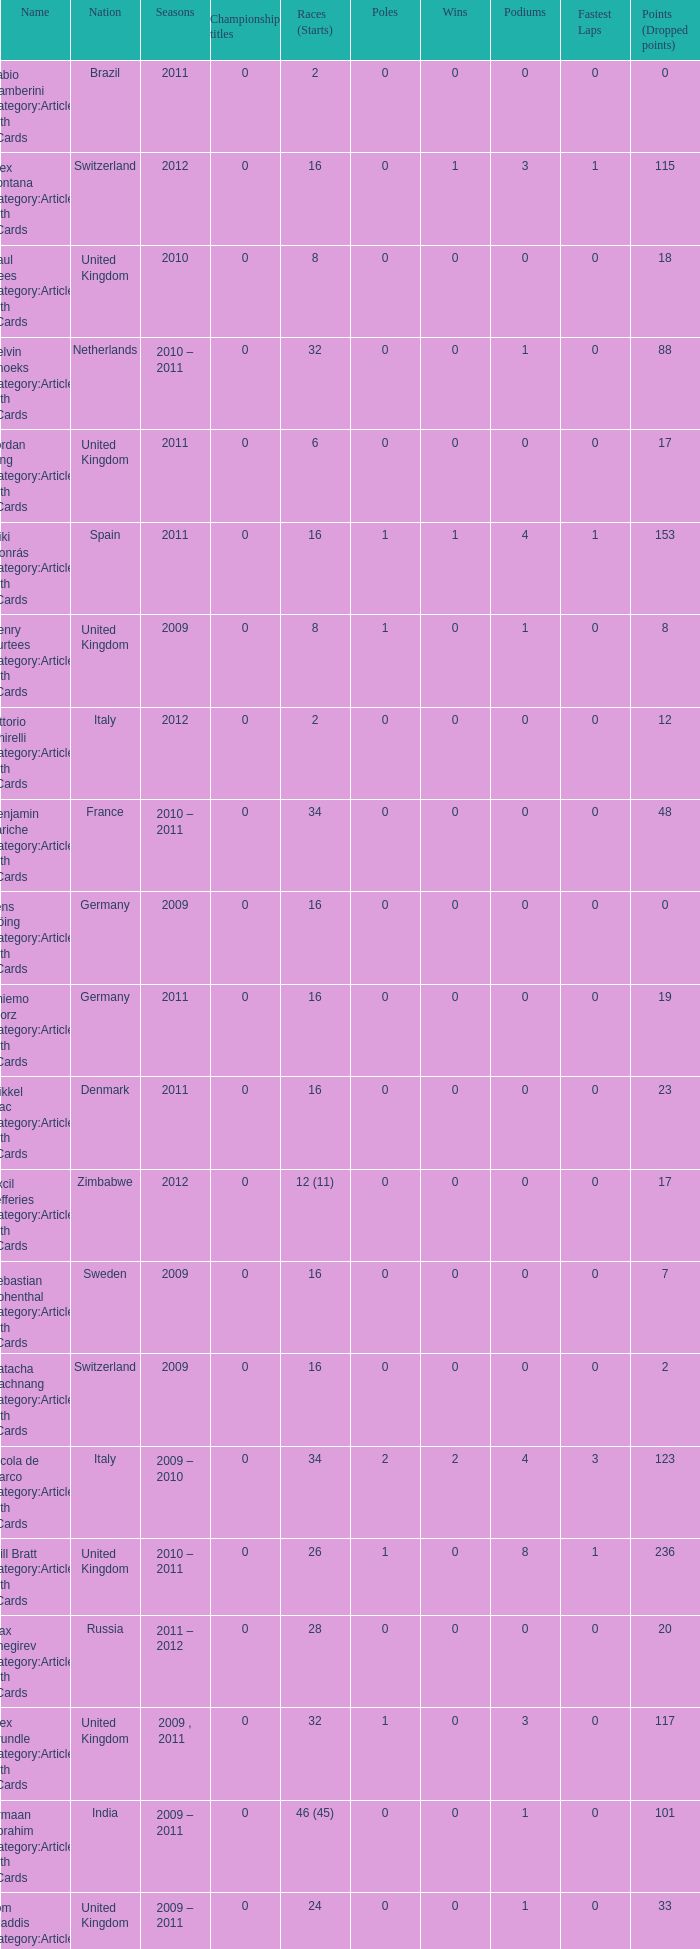When did they win 7 races? 2009.0. Would you mind parsing the complete table? {'header': ['Name', 'Nation', 'Seasons', 'Championship titles', 'Races (Starts)', 'Poles', 'Wins', 'Podiums', 'Fastest Laps', 'Points (Dropped points)'], 'rows': [['Fabio Gamberini Category:Articles with hCards', 'Brazil', '2011', '0', '2', '0', '0', '0', '0', '0'], ['Alex Fontana Category:Articles with hCards', 'Switzerland', '2012', '0', '16', '0', '1', '3', '1', '115'], ['Paul Rees Category:Articles with hCards', 'United Kingdom', '2010', '0', '8', '0', '0', '0', '0', '18'], ['Kelvin Snoeks Category:Articles with hCards', 'Netherlands', '2010 – 2011', '0', '32', '0', '0', '1', '0', '88'], ['Jordan King Category:Articles with hCards', 'United Kingdom', '2011', '0', '6', '0', '0', '0', '0', '17'], ['Miki Monrás Category:Articles with hCards', 'Spain', '2011', '0', '16', '1', '1', '4', '1', '153'], ['Henry Surtees Category:Articles with hCards', 'United Kingdom', '2009', '0', '8', '1', '0', '1', '0', '8'], ['Vittorio Ghirelli Category:Articles with hCards', 'Italy', '2012', '0', '2', '0', '0', '0', '0', '12'], ['Benjamin Lariche Category:Articles with hCards', 'France', '2010 – 2011', '0', '34', '0', '0', '0', '0', '48'], ['Jens Höing Category:Articles with hCards', 'Germany', '2009', '0', '16', '0', '0', '0', '0', '0'], ['Thiemo Storz Category:Articles with hCards', 'Germany', '2011', '0', '16', '0', '0', '0', '0', '19'], ['Mikkel Mac Category:Articles with hCards', 'Denmark', '2011', '0', '16', '0', '0', '0', '0', '23'], ['Axcil Jefferies Category:Articles with hCards', 'Zimbabwe', '2012', '0', '12 (11)', '0', '0', '0', '0', '17'], ['Sebastian Hohenthal Category:Articles with hCards', 'Sweden', '2009', '0', '16', '0', '0', '0', '0', '7'], ['Natacha Gachnang Category:Articles with hCards', 'Switzerland', '2009', '0', '16', '0', '0', '0', '0', '2'], ['Nicola de Marco Category:Articles with hCards', 'Italy', '2009 – 2010', '0', '34', '2', '2', '4', '3', '123'], ['Will Bratt Category:Articles with hCards', 'United Kingdom', '2010 – 2011', '0', '26', '1', '0', '8', '1', '236'], ['Max Snegirev Category:Articles with hCards', 'Russia', '2011 – 2012', '0', '28', '0', '0', '0', '0', '20'], ['Alex Brundle Category:Articles with hCards', 'United Kingdom', '2009 , 2011', '0', '32', '1', '0', '3', '0', '117'], ['Armaan Ebrahim Category:Articles with hCards', 'India', '2009 – 2011', '0', '46 (45)', '0', '0', '1', '0', '101'], ['Tom Gladdis Category:Articles with hCards', 'United Kingdom', '2009 – 2011', '0', '24', '0', '0', '1', '0', '33'], ['Andy Soucek Category:Articles with hCards', 'Spain', '2009', '1 ( 2009 )', '16', '2', '7', '11', '3', '115'], ['Christopher Zanella Category:Articles with hCards', 'Switzerland', '2011 – 2012', '0', '32', '3', '4', '14', '5', '385 (401)'], ['Mihai Marinescu Category:Articles with hCards', 'Romania', '2010 – 2012', '0', '50', '4', '3', '8', '4', '299'], ['Julian Theobald Category:Articles with hCards', 'Germany', '2010 – 2011', '0', '18', '0', '0', '0', '0', '8'], ['Robert Wickens Category:Articles with hCards', 'Canada', '2009', '0', '16', '5', '2', '6', '3', '64'], ['Henri Karjalainen Category:Articles with hCards', 'Finland', '2009', '0', '16', '0', '0', '0', '0', '7'], ['Ivan Samarin Category:Articles with hCards', 'Russia', '2010', '0', '18', '0', '0', '0', '0', '64'], ['Kourosh Khani Category:Articles with hCards', 'Iran', '2012', '0', '8', '0', '0', '0', '0', '2'], ['Jon Lancaster Category:Articles with hCards', 'United Kingdom', '2011', '0', '2', '0', '0', '0', '0', '14'], ['Jack Clarke Category:Articles with hCards', 'United Kingdom', '2009 – 2011', '0', '50 (49)', '0', '1', '3', '1', '197'], ['Samuele Buttarelli Category:Articles with hCards', 'Italy', '2012', '0', '2', '0', '0', '0', '0', '0'], ['Natalia Kowalska Category:Articles with hCards', 'Poland', '2010 – 2011', '0', '20', '0', '0', '0', '0', '3'], ['Edoardo Piscopo Category:Articles with hCards', 'Italy', '2009', '0', '14', '0', '0', '0', '0', '19'], ['Ollie Hancock Category:Articles with hCards', 'United Kingdom', '2009', '0', '6', '0', '0', '0', '0', '0'], ['Jason Moore Category:Articles with hCards', 'United Kingdom', '2009', '0', '16 (15)', '0', '0', '0', '0', '3'], ['Mirko Bortolotti Category:Articles with hCards', 'Italy', '2009 , 2011', '1 ( 2011 )', '32', '7', '8', '19', '8', '339 (366)'], ['Miloš Pavlović Category:Articles with hCards', 'Serbia', '2009', '0', '16', '0', '0', '2', '1', '29'], ['Benjamin Bailly Category:Articles with hCards', 'Belgium', '2010', '0', '18', '1', '1', '3', '0', '130'], ['Parthiva Sureshwaren Category:Articles with hCards', 'India', '2010 – 2012', '0', '32 (31)', '0', '0', '0', '0', '1'], ['Jolyon Palmer Category:Articles with hCards', 'United Kingdom', '2009 – 2010', '0', '34 (36)', '5', '5', '10', '3', '245'], ['Kazim Vasiliauskas Category:Articles with hCards', 'Lithuania', '2009 – 2010', '0', '34', '3', '2', '10', '4', '198'], ['Dino Zamparelli Category:Articles with hCards', 'United Kingdom', '2012', '0', '16', '0', '0', '2', '0', '106.5'], ['Julien Jousse Category:Articles with hCards', 'France', '2009', '0', '16', '1', '1', '4', '2', '49'], ['Mathéo Tuscher Category:Articles with hCards', 'Switzerland', '2012', '0', '16', '4', '2', '9', '1', '210'], ['René Binder Category:Articles with hCards', 'Austria', '2011', '0', '2', '0', '0', '0', '0', '0'], ['Mauro Calamia Category:Articles with hCards', 'Switzerland', '2012', '0', '12', '0', '0', '0', '0', '2'], ['Johan Jokinen Category:Articles with hCards', 'Denmark', '2010', '0', '6', '0', '0', '1', '1', '21'], ['Mikhail Aleshin Category:Articles with hCards', 'Russia', '2009', '0', '16', '1', '1', '5', '0', '59'], ['Sung-Hak Mun Category:Articles with hCards', 'South Korea', '2011', '0', '16 (15)', '0', '0', '0', '0', '0'], ['Markus Pommer Category:Articles with hCards', 'Germany', '2012', '0', '16', '4', '3', '5', '2', '169'], ['Luciano Bacheta Category:Articles with hCards', 'United Kingdom', '2011 – 2012', '1 ( 2012 )', '20', '3', '5', '10', '5', '249.5 (253.5)'], ['José Luis Abadín Category:Articles with hCards', 'Spain', '2011 – 2012', '0', '12', '0', '0', '0', '0', '1'], ['Tristan Vautier Category:Articles with hCards', 'France', '2009', '0', '2', '0', '0', '1', '0', '9'], ['Philipp Eng Category:Articles with hCards', 'Austria', '2009 – 2010', '0', '34', '3', '4', '7', '1', '181'], ['Pietro Gandolfi Category:Articles with hCards', 'Italy', '2009', '0', '16', '0', '0', '0', '0', '0'], ['Kevin Mirocha Category:Articles with hCards', 'Poland', '2012', '0', '16', '1', '1', '6', '0', '159.5'], ['Victor Guerin Category:Articles with hCards', 'Brazil', '2012', '0', '2', '0', '0', '0', '0', '2'], ['Ramón Piñeiro Category:Articles with hCards', 'Spain', '2010 – 2011', '0', '18', '2', '3', '7', '2', '186'], ['Daniel McKenzie Category:Articles with hCards', 'United Kingdom', '2012', '0', '16', '0', '0', '2', '0', '95'], ['Dean Stoneman Category:Articles with hCards', 'United Kingdom', '2010', '1 ( 2010 )', '18', '6', '6', '13', '6', '284'], ['Germán Sánchez Category:Articles with hCards', 'Spain', '2009', '0', '16 (14)', '0', '0', '0', '0', '2'], ['Carlos Iaconelli Category:Articles with hCards', 'Brazil', '2009', '0', '14', '0', '0', '1', '0', '21'], ['Ajith Kumar Category:Articles with hCards', 'India', '2010', '0', '6', '0', '0', '0', '0', '0'], ['Harald Schlegelmilch Category:Articles with hCards', 'Latvia', '2012', '0', '2', '0', '0', '0', '0', '12'], ['Sergey Afanasyev Category:Articles with hCards', 'Russia', '2010', '0', '18', '1', '0', '4', '1', '157'], ['Plamen Kralev Category:Articles with hCards', 'Bulgaria', '2010 – 2012', '0', '50 (49)', '0', '0', '0', '0', '6'], ['Hector Hurst Category:Articles with hCards', 'United Kingdom', '2012', '0', '16', '0', '0', '0', '0', '27'], ['Richard Gonda Category:Articles with hCards', 'Slovakia', '2012', '0', '2', '0', '0', '0', '0', '4'], ['Johannes Theobald Category:Articles with hCards', 'Germany', '2010 – 2011', '0', '14', '0', '0', '0', '0', '1'], ['Ricardo Teixeira Category:Articles with hCards', 'Angola', '2010', '0', '18', '0', '0', '0', '0', '23'], ['Tobias Hegewald Category:Articles with hCards', 'Germany', '2009 , 2011', '0', '32', '4', '2', '5', '3', '158']]} 